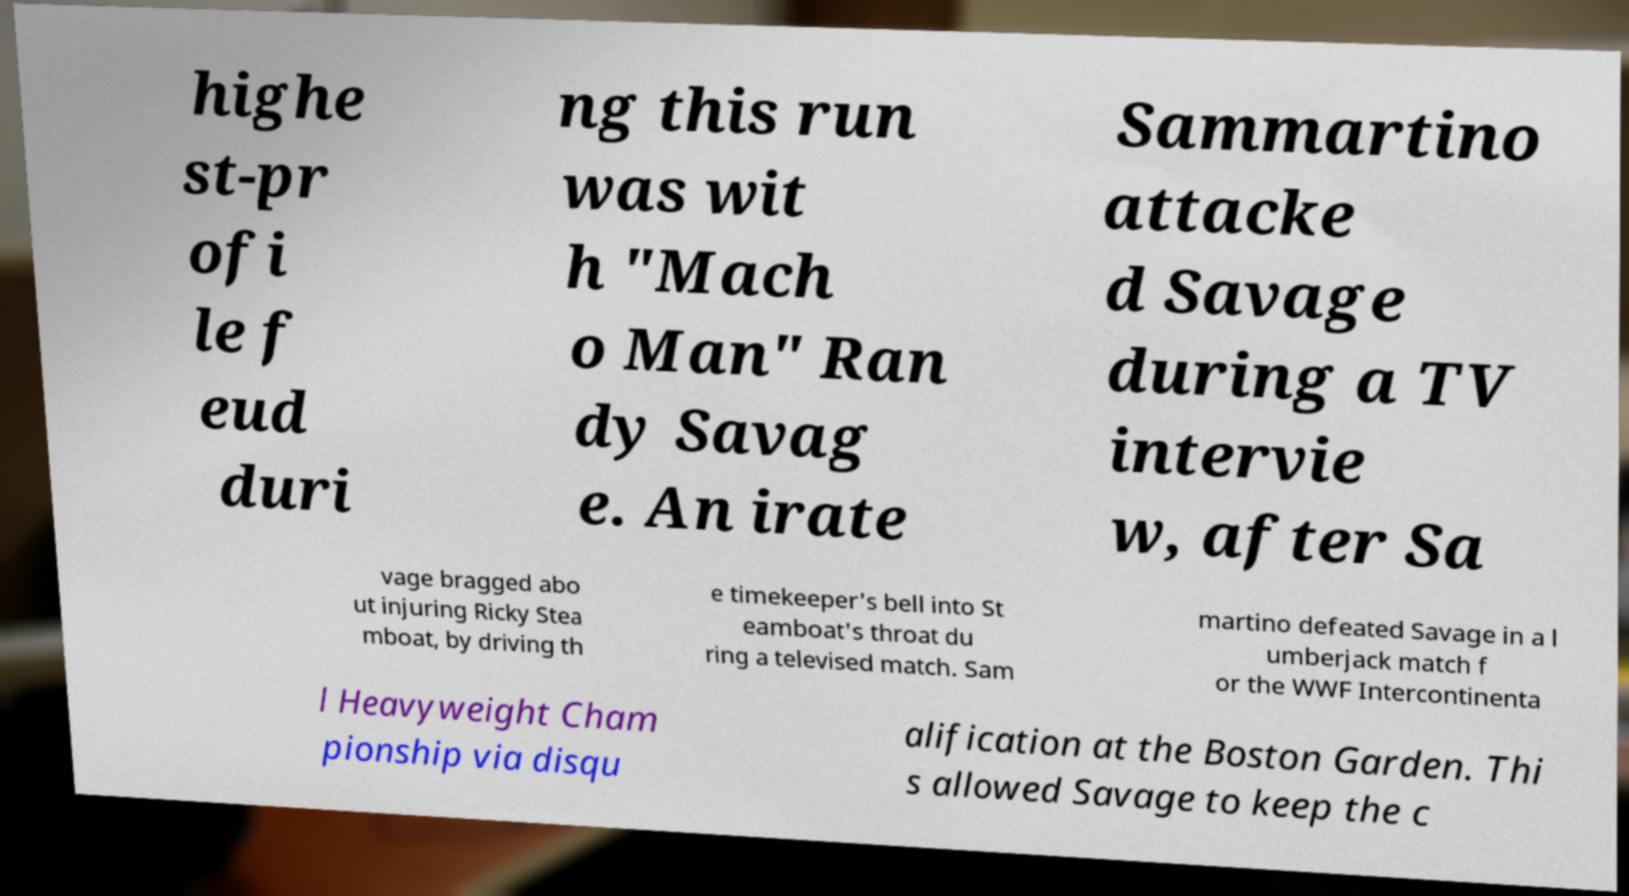For documentation purposes, I need the text within this image transcribed. Could you provide that? highe st-pr ofi le f eud duri ng this run was wit h "Mach o Man" Ran dy Savag e. An irate Sammartino attacke d Savage during a TV intervie w, after Sa vage bragged abo ut injuring Ricky Stea mboat, by driving th e timekeeper's bell into St eamboat's throat du ring a televised match. Sam martino defeated Savage in a l umberjack match f or the WWF Intercontinenta l Heavyweight Cham pionship via disqu alification at the Boston Garden. Thi s allowed Savage to keep the c 